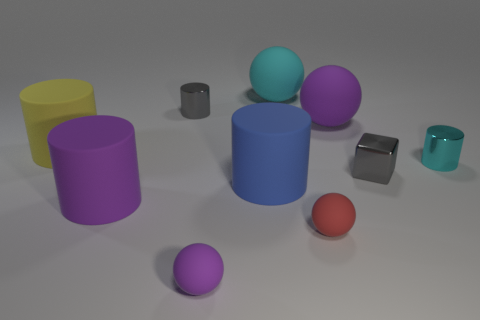Subtract all yellow cylinders. How many cylinders are left? 4 Subtract all cyan cylinders. How many cylinders are left? 4 Subtract all green balls. Subtract all cyan cylinders. How many balls are left? 4 Subtract all blocks. How many objects are left? 9 Add 2 large cyan rubber balls. How many large cyan rubber balls exist? 3 Subtract 1 gray cylinders. How many objects are left? 9 Subtract all gray matte cubes. Subtract all large purple rubber cylinders. How many objects are left? 9 Add 9 big cyan spheres. How many big cyan spheres are left? 10 